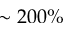Convert formula to latex. <formula><loc_0><loc_0><loc_500><loc_500>\sim 2 0 0 \%</formula> 